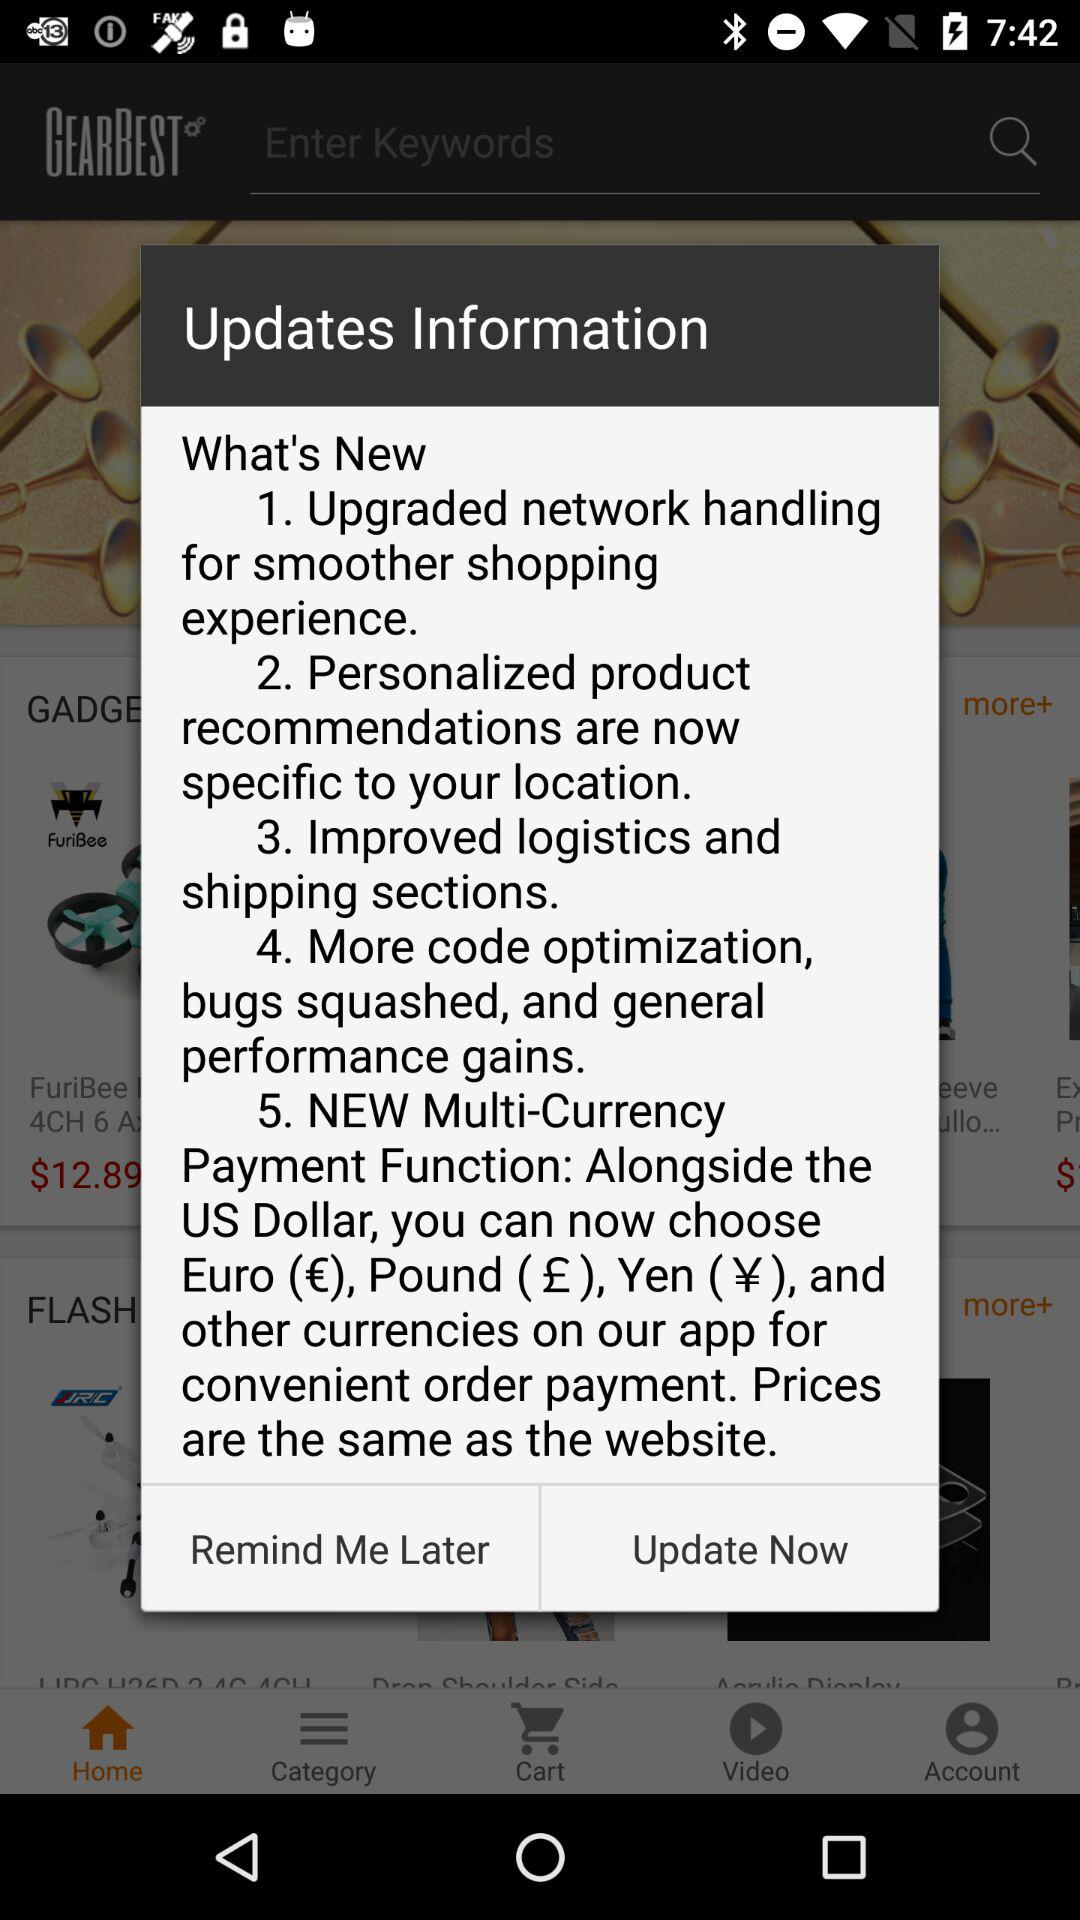How many new features are there in the update?
Answer the question using a single word or phrase. 5 